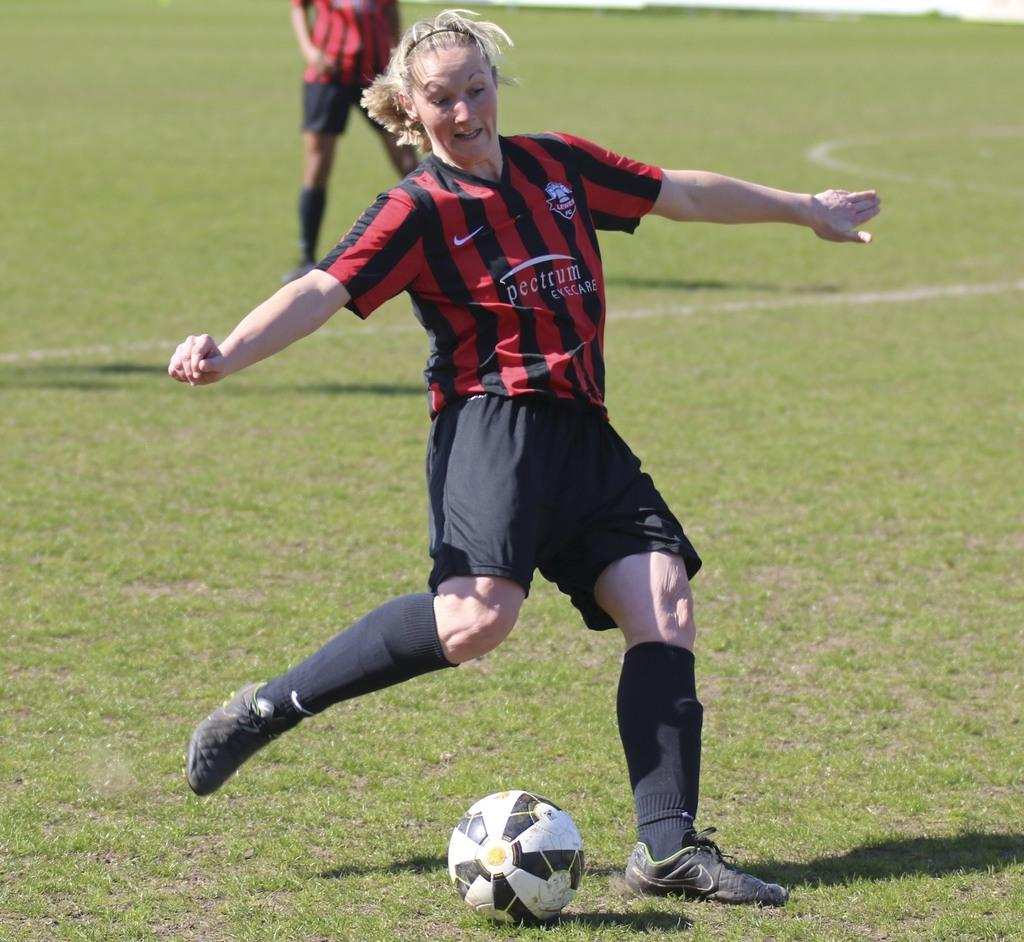Who is the main subject in the image? There is a woman in the image. What is the woman doing in the image? The woman is running in the image. What can be seen on the grass in the image? There is a ball on the grass in the image. Can you describe the person in the background of the image? There is a person standing far away in the image. What type of leaf is the bear holding in the image? There is no bear or leaf present in the image. 